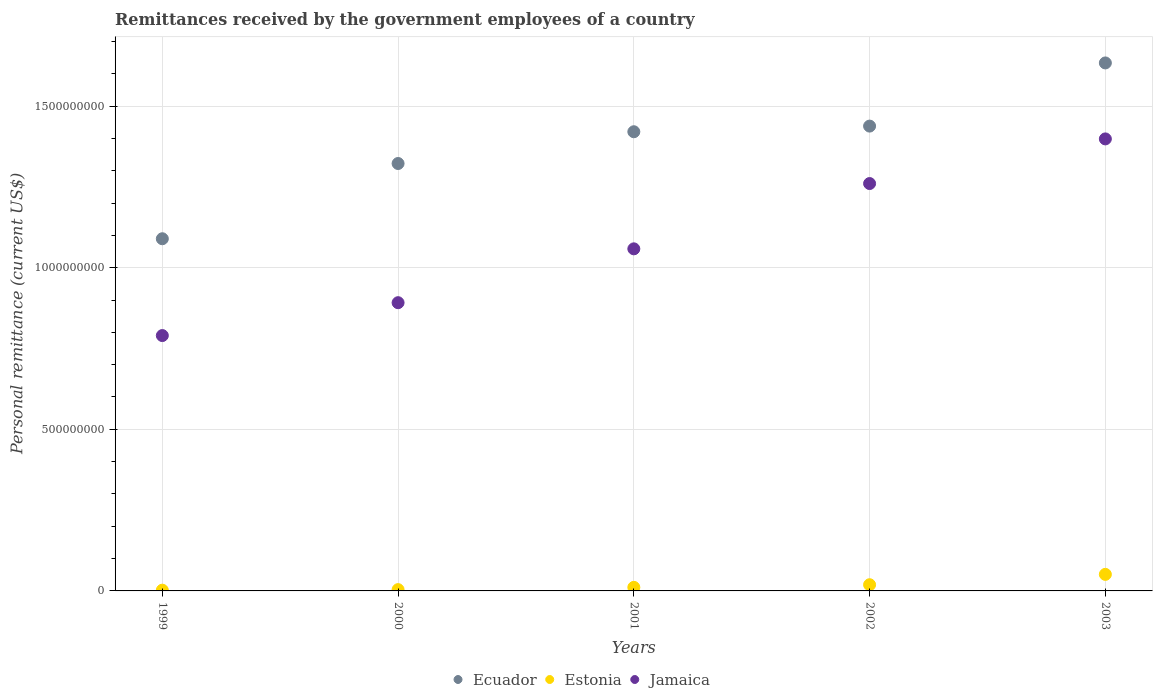How many different coloured dotlines are there?
Your answer should be very brief. 3. Is the number of dotlines equal to the number of legend labels?
Provide a succinct answer. Yes. What is the remittances received by the government employees in Ecuador in 2003?
Provide a short and direct response. 1.63e+09. Across all years, what is the maximum remittances received by the government employees in Ecuador?
Provide a short and direct response. 1.63e+09. Across all years, what is the minimum remittances received by the government employees in Ecuador?
Provide a short and direct response. 1.09e+09. What is the total remittances received by the government employees in Ecuador in the graph?
Your response must be concise. 6.90e+09. What is the difference between the remittances received by the government employees in Ecuador in 1999 and that in 2001?
Provide a succinct answer. -3.31e+08. What is the difference between the remittances received by the government employees in Estonia in 1999 and the remittances received by the government employees in Jamaica in 2001?
Ensure brevity in your answer.  -1.06e+09. What is the average remittances received by the government employees in Estonia per year?
Keep it short and to the point. 1.75e+07. In the year 2000, what is the difference between the remittances received by the government employees in Ecuador and remittances received by the government employees in Jamaica?
Offer a very short reply. 4.31e+08. In how many years, is the remittances received by the government employees in Jamaica greater than 1300000000 US$?
Your answer should be very brief. 1. What is the ratio of the remittances received by the government employees in Estonia in 2000 to that in 2001?
Give a very brief answer. 0.37. What is the difference between the highest and the second highest remittances received by the government employees in Jamaica?
Your answer should be compact. 1.38e+08. What is the difference between the highest and the lowest remittances received by the government employees in Ecuador?
Provide a short and direct response. 5.44e+08. Is it the case that in every year, the sum of the remittances received by the government employees in Jamaica and remittances received by the government employees in Ecuador  is greater than the remittances received by the government employees in Estonia?
Provide a succinct answer. Yes. Does the remittances received by the government employees in Jamaica monotonically increase over the years?
Provide a succinct answer. Yes. Is the remittances received by the government employees in Estonia strictly less than the remittances received by the government employees in Jamaica over the years?
Ensure brevity in your answer.  Yes. How many dotlines are there?
Offer a very short reply. 3. How many years are there in the graph?
Your response must be concise. 5. What is the difference between two consecutive major ticks on the Y-axis?
Your response must be concise. 5.00e+08. Does the graph contain grids?
Ensure brevity in your answer.  Yes. Where does the legend appear in the graph?
Provide a succinct answer. Bottom center. How many legend labels are there?
Offer a very short reply. 3. How are the legend labels stacked?
Offer a very short reply. Horizontal. What is the title of the graph?
Your answer should be compact. Remittances received by the government employees of a country. What is the label or title of the Y-axis?
Provide a short and direct response. Personal remittance (current US$). What is the Personal remittance (current US$) of Ecuador in 1999?
Your response must be concise. 1.09e+09. What is the Personal remittance (current US$) in Estonia in 1999?
Keep it short and to the point. 2.31e+06. What is the Personal remittance (current US$) of Jamaica in 1999?
Provide a short and direct response. 7.90e+08. What is the Personal remittance (current US$) of Ecuador in 2000?
Provide a succinct answer. 1.32e+09. What is the Personal remittance (current US$) in Estonia in 2000?
Offer a very short reply. 4.05e+06. What is the Personal remittance (current US$) in Jamaica in 2000?
Your response must be concise. 8.92e+08. What is the Personal remittance (current US$) in Ecuador in 2001?
Your response must be concise. 1.42e+09. What is the Personal remittance (current US$) in Estonia in 2001?
Keep it short and to the point. 1.10e+07. What is the Personal remittance (current US$) of Jamaica in 2001?
Ensure brevity in your answer.  1.06e+09. What is the Personal remittance (current US$) in Ecuador in 2002?
Provide a succinct answer. 1.44e+09. What is the Personal remittance (current US$) of Estonia in 2002?
Offer a terse response. 1.91e+07. What is the Personal remittance (current US$) of Jamaica in 2002?
Your response must be concise. 1.26e+09. What is the Personal remittance (current US$) in Ecuador in 2003?
Keep it short and to the point. 1.63e+09. What is the Personal remittance (current US$) in Estonia in 2003?
Ensure brevity in your answer.  5.12e+07. What is the Personal remittance (current US$) of Jamaica in 2003?
Your answer should be compact. 1.40e+09. Across all years, what is the maximum Personal remittance (current US$) in Ecuador?
Make the answer very short. 1.63e+09. Across all years, what is the maximum Personal remittance (current US$) in Estonia?
Provide a succinct answer. 5.12e+07. Across all years, what is the maximum Personal remittance (current US$) of Jamaica?
Your response must be concise. 1.40e+09. Across all years, what is the minimum Personal remittance (current US$) of Ecuador?
Your answer should be very brief. 1.09e+09. Across all years, what is the minimum Personal remittance (current US$) of Estonia?
Your answer should be very brief. 2.31e+06. Across all years, what is the minimum Personal remittance (current US$) of Jamaica?
Your response must be concise. 7.90e+08. What is the total Personal remittance (current US$) of Ecuador in the graph?
Offer a terse response. 6.90e+09. What is the total Personal remittance (current US$) in Estonia in the graph?
Your answer should be very brief. 8.77e+07. What is the total Personal remittance (current US$) of Jamaica in the graph?
Provide a succinct answer. 5.40e+09. What is the difference between the Personal remittance (current US$) of Ecuador in 1999 and that in 2000?
Your answer should be very brief. -2.33e+08. What is the difference between the Personal remittance (current US$) in Estonia in 1999 and that in 2000?
Your answer should be very brief. -1.74e+06. What is the difference between the Personal remittance (current US$) in Jamaica in 1999 and that in 2000?
Your response must be concise. -1.02e+08. What is the difference between the Personal remittance (current US$) in Ecuador in 1999 and that in 2001?
Your response must be concise. -3.31e+08. What is the difference between the Personal remittance (current US$) of Estonia in 1999 and that in 2001?
Offer a terse response. -8.71e+06. What is the difference between the Personal remittance (current US$) of Jamaica in 1999 and that in 2001?
Your answer should be compact. -2.68e+08. What is the difference between the Personal remittance (current US$) in Ecuador in 1999 and that in 2002?
Keep it short and to the point. -3.49e+08. What is the difference between the Personal remittance (current US$) in Estonia in 1999 and that in 2002?
Provide a succinct answer. -1.68e+07. What is the difference between the Personal remittance (current US$) of Jamaica in 1999 and that in 2002?
Keep it short and to the point. -4.70e+08. What is the difference between the Personal remittance (current US$) in Ecuador in 1999 and that in 2003?
Your answer should be very brief. -5.44e+08. What is the difference between the Personal remittance (current US$) in Estonia in 1999 and that in 2003?
Offer a terse response. -4.89e+07. What is the difference between the Personal remittance (current US$) of Jamaica in 1999 and that in 2003?
Offer a terse response. -6.08e+08. What is the difference between the Personal remittance (current US$) in Ecuador in 2000 and that in 2001?
Make the answer very short. -9.83e+07. What is the difference between the Personal remittance (current US$) in Estonia in 2000 and that in 2001?
Offer a very short reply. -6.97e+06. What is the difference between the Personal remittance (current US$) in Jamaica in 2000 and that in 2001?
Ensure brevity in your answer.  -1.67e+08. What is the difference between the Personal remittance (current US$) in Ecuador in 2000 and that in 2002?
Give a very brief answer. -1.16e+08. What is the difference between the Personal remittance (current US$) in Estonia in 2000 and that in 2002?
Ensure brevity in your answer.  -1.51e+07. What is the difference between the Personal remittance (current US$) of Jamaica in 2000 and that in 2002?
Make the answer very short. -3.69e+08. What is the difference between the Personal remittance (current US$) in Ecuador in 2000 and that in 2003?
Give a very brief answer. -3.11e+08. What is the difference between the Personal remittance (current US$) of Estonia in 2000 and that in 2003?
Make the answer very short. -4.72e+07. What is the difference between the Personal remittance (current US$) of Jamaica in 2000 and that in 2003?
Ensure brevity in your answer.  -5.07e+08. What is the difference between the Personal remittance (current US$) in Ecuador in 2001 and that in 2002?
Keep it short and to the point. -1.75e+07. What is the difference between the Personal remittance (current US$) of Estonia in 2001 and that in 2002?
Your answer should be compact. -8.13e+06. What is the difference between the Personal remittance (current US$) in Jamaica in 2001 and that in 2002?
Provide a short and direct response. -2.02e+08. What is the difference between the Personal remittance (current US$) of Ecuador in 2001 and that in 2003?
Offer a very short reply. -2.13e+08. What is the difference between the Personal remittance (current US$) in Estonia in 2001 and that in 2003?
Your answer should be compact. -4.02e+07. What is the difference between the Personal remittance (current US$) of Jamaica in 2001 and that in 2003?
Provide a short and direct response. -3.40e+08. What is the difference between the Personal remittance (current US$) in Ecuador in 2002 and that in 2003?
Your answer should be compact. -1.95e+08. What is the difference between the Personal remittance (current US$) of Estonia in 2002 and that in 2003?
Make the answer very short. -3.21e+07. What is the difference between the Personal remittance (current US$) of Jamaica in 2002 and that in 2003?
Keep it short and to the point. -1.38e+08. What is the difference between the Personal remittance (current US$) in Ecuador in 1999 and the Personal remittance (current US$) in Estonia in 2000?
Make the answer very short. 1.09e+09. What is the difference between the Personal remittance (current US$) of Ecuador in 1999 and the Personal remittance (current US$) of Jamaica in 2000?
Keep it short and to the point. 1.98e+08. What is the difference between the Personal remittance (current US$) of Estonia in 1999 and the Personal remittance (current US$) of Jamaica in 2000?
Offer a terse response. -8.89e+08. What is the difference between the Personal remittance (current US$) in Ecuador in 1999 and the Personal remittance (current US$) in Estonia in 2001?
Keep it short and to the point. 1.08e+09. What is the difference between the Personal remittance (current US$) of Ecuador in 1999 and the Personal remittance (current US$) of Jamaica in 2001?
Your answer should be very brief. 3.12e+07. What is the difference between the Personal remittance (current US$) in Estonia in 1999 and the Personal remittance (current US$) in Jamaica in 2001?
Ensure brevity in your answer.  -1.06e+09. What is the difference between the Personal remittance (current US$) of Ecuador in 1999 and the Personal remittance (current US$) of Estonia in 2002?
Keep it short and to the point. 1.07e+09. What is the difference between the Personal remittance (current US$) in Ecuador in 1999 and the Personal remittance (current US$) in Jamaica in 2002?
Your response must be concise. -1.71e+08. What is the difference between the Personal remittance (current US$) in Estonia in 1999 and the Personal remittance (current US$) in Jamaica in 2002?
Offer a very short reply. -1.26e+09. What is the difference between the Personal remittance (current US$) of Ecuador in 1999 and the Personal remittance (current US$) of Estonia in 2003?
Provide a short and direct response. 1.04e+09. What is the difference between the Personal remittance (current US$) of Ecuador in 1999 and the Personal remittance (current US$) of Jamaica in 2003?
Provide a short and direct response. -3.09e+08. What is the difference between the Personal remittance (current US$) in Estonia in 1999 and the Personal remittance (current US$) in Jamaica in 2003?
Your response must be concise. -1.40e+09. What is the difference between the Personal remittance (current US$) of Ecuador in 2000 and the Personal remittance (current US$) of Estonia in 2001?
Offer a very short reply. 1.31e+09. What is the difference between the Personal remittance (current US$) of Ecuador in 2000 and the Personal remittance (current US$) of Jamaica in 2001?
Provide a short and direct response. 2.64e+08. What is the difference between the Personal remittance (current US$) of Estonia in 2000 and the Personal remittance (current US$) of Jamaica in 2001?
Give a very brief answer. -1.05e+09. What is the difference between the Personal remittance (current US$) in Ecuador in 2000 and the Personal remittance (current US$) in Estonia in 2002?
Your response must be concise. 1.30e+09. What is the difference between the Personal remittance (current US$) of Ecuador in 2000 and the Personal remittance (current US$) of Jamaica in 2002?
Provide a succinct answer. 6.20e+07. What is the difference between the Personal remittance (current US$) of Estonia in 2000 and the Personal remittance (current US$) of Jamaica in 2002?
Offer a very short reply. -1.26e+09. What is the difference between the Personal remittance (current US$) of Ecuador in 2000 and the Personal remittance (current US$) of Estonia in 2003?
Your answer should be very brief. 1.27e+09. What is the difference between the Personal remittance (current US$) of Ecuador in 2000 and the Personal remittance (current US$) of Jamaica in 2003?
Your answer should be very brief. -7.61e+07. What is the difference between the Personal remittance (current US$) in Estonia in 2000 and the Personal remittance (current US$) in Jamaica in 2003?
Offer a very short reply. -1.39e+09. What is the difference between the Personal remittance (current US$) in Ecuador in 2001 and the Personal remittance (current US$) in Estonia in 2002?
Keep it short and to the point. 1.40e+09. What is the difference between the Personal remittance (current US$) in Ecuador in 2001 and the Personal remittance (current US$) in Jamaica in 2002?
Give a very brief answer. 1.60e+08. What is the difference between the Personal remittance (current US$) of Estonia in 2001 and the Personal remittance (current US$) of Jamaica in 2002?
Make the answer very short. -1.25e+09. What is the difference between the Personal remittance (current US$) of Ecuador in 2001 and the Personal remittance (current US$) of Estonia in 2003?
Your answer should be very brief. 1.37e+09. What is the difference between the Personal remittance (current US$) in Ecuador in 2001 and the Personal remittance (current US$) in Jamaica in 2003?
Offer a very short reply. 2.22e+07. What is the difference between the Personal remittance (current US$) in Estonia in 2001 and the Personal remittance (current US$) in Jamaica in 2003?
Your answer should be compact. -1.39e+09. What is the difference between the Personal remittance (current US$) of Ecuador in 2002 and the Personal remittance (current US$) of Estonia in 2003?
Make the answer very short. 1.39e+09. What is the difference between the Personal remittance (current US$) in Ecuador in 2002 and the Personal remittance (current US$) in Jamaica in 2003?
Offer a terse response. 3.96e+07. What is the difference between the Personal remittance (current US$) in Estonia in 2002 and the Personal remittance (current US$) in Jamaica in 2003?
Provide a succinct answer. -1.38e+09. What is the average Personal remittance (current US$) in Ecuador per year?
Make the answer very short. 1.38e+09. What is the average Personal remittance (current US$) in Estonia per year?
Your answer should be compact. 1.75e+07. What is the average Personal remittance (current US$) in Jamaica per year?
Keep it short and to the point. 1.08e+09. In the year 1999, what is the difference between the Personal remittance (current US$) of Ecuador and Personal remittance (current US$) of Estonia?
Your answer should be very brief. 1.09e+09. In the year 1999, what is the difference between the Personal remittance (current US$) in Ecuador and Personal remittance (current US$) in Jamaica?
Give a very brief answer. 3.00e+08. In the year 1999, what is the difference between the Personal remittance (current US$) in Estonia and Personal remittance (current US$) in Jamaica?
Provide a succinct answer. -7.88e+08. In the year 2000, what is the difference between the Personal remittance (current US$) of Ecuador and Personal remittance (current US$) of Estonia?
Provide a succinct answer. 1.32e+09. In the year 2000, what is the difference between the Personal remittance (current US$) of Ecuador and Personal remittance (current US$) of Jamaica?
Give a very brief answer. 4.31e+08. In the year 2000, what is the difference between the Personal remittance (current US$) of Estonia and Personal remittance (current US$) of Jamaica?
Offer a terse response. -8.88e+08. In the year 2001, what is the difference between the Personal remittance (current US$) of Ecuador and Personal remittance (current US$) of Estonia?
Ensure brevity in your answer.  1.41e+09. In the year 2001, what is the difference between the Personal remittance (current US$) in Ecuador and Personal remittance (current US$) in Jamaica?
Provide a short and direct response. 3.62e+08. In the year 2001, what is the difference between the Personal remittance (current US$) of Estonia and Personal remittance (current US$) of Jamaica?
Provide a succinct answer. -1.05e+09. In the year 2002, what is the difference between the Personal remittance (current US$) of Ecuador and Personal remittance (current US$) of Estonia?
Offer a terse response. 1.42e+09. In the year 2002, what is the difference between the Personal remittance (current US$) in Ecuador and Personal remittance (current US$) in Jamaica?
Offer a very short reply. 1.78e+08. In the year 2002, what is the difference between the Personal remittance (current US$) of Estonia and Personal remittance (current US$) of Jamaica?
Offer a very short reply. -1.24e+09. In the year 2003, what is the difference between the Personal remittance (current US$) in Ecuador and Personal remittance (current US$) in Estonia?
Make the answer very short. 1.58e+09. In the year 2003, what is the difference between the Personal remittance (current US$) in Ecuador and Personal remittance (current US$) in Jamaica?
Your answer should be very brief. 2.35e+08. In the year 2003, what is the difference between the Personal remittance (current US$) in Estonia and Personal remittance (current US$) in Jamaica?
Make the answer very short. -1.35e+09. What is the ratio of the Personal remittance (current US$) of Ecuador in 1999 to that in 2000?
Give a very brief answer. 0.82. What is the ratio of the Personal remittance (current US$) of Estonia in 1999 to that in 2000?
Offer a very short reply. 0.57. What is the ratio of the Personal remittance (current US$) of Jamaica in 1999 to that in 2000?
Provide a short and direct response. 0.89. What is the ratio of the Personal remittance (current US$) of Ecuador in 1999 to that in 2001?
Offer a terse response. 0.77. What is the ratio of the Personal remittance (current US$) in Estonia in 1999 to that in 2001?
Make the answer very short. 0.21. What is the ratio of the Personal remittance (current US$) in Jamaica in 1999 to that in 2001?
Make the answer very short. 0.75. What is the ratio of the Personal remittance (current US$) in Ecuador in 1999 to that in 2002?
Your answer should be compact. 0.76. What is the ratio of the Personal remittance (current US$) of Estonia in 1999 to that in 2002?
Offer a very short reply. 0.12. What is the ratio of the Personal remittance (current US$) in Jamaica in 1999 to that in 2002?
Offer a terse response. 0.63. What is the ratio of the Personal remittance (current US$) in Ecuador in 1999 to that in 2003?
Ensure brevity in your answer.  0.67. What is the ratio of the Personal remittance (current US$) in Estonia in 1999 to that in 2003?
Provide a short and direct response. 0.05. What is the ratio of the Personal remittance (current US$) of Jamaica in 1999 to that in 2003?
Provide a short and direct response. 0.56. What is the ratio of the Personal remittance (current US$) in Ecuador in 2000 to that in 2001?
Offer a very short reply. 0.93. What is the ratio of the Personal remittance (current US$) in Estonia in 2000 to that in 2001?
Offer a very short reply. 0.37. What is the ratio of the Personal remittance (current US$) in Jamaica in 2000 to that in 2001?
Provide a succinct answer. 0.84. What is the ratio of the Personal remittance (current US$) in Ecuador in 2000 to that in 2002?
Give a very brief answer. 0.92. What is the ratio of the Personal remittance (current US$) of Estonia in 2000 to that in 2002?
Ensure brevity in your answer.  0.21. What is the ratio of the Personal remittance (current US$) in Jamaica in 2000 to that in 2002?
Give a very brief answer. 0.71. What is the ratio of the Personal remittance (current US$) in Ecuador in 2000 to that in 2003?
Your response must be concise. 0.81. What is the ratio of the Personal remittance (current US$) in Estonia in 2000 to that in 2003?
Offer a terse response. 0.08. What is the ratio of the Personal remittance (current US$) of Jamaica in 2000 to that in 2003?
Your answer should be very brief. 0.64. What is the ratio of the Personal remittance (current US$) in Ecuador in 2001 to that in 2002?
Ensure brevity in your answer.  0.99. What is the ratio of the Personal remittance (current US$) in Estonia in 2001 to that in 2002?
Ensure brevity in your answer.  0.58. What is the ratio of the Personal remittance (current US$) in Jamaica in 2001 to that in 2002?
Make the answer very short. 0.84. What is the ratio of the Personal remittance (current US$) in Ecuador in 2001 to that in 2003?
Offer a very short reply. 0.87. What is the ratio of the Personal remittance (current US$) in Estonia in 2001 to that in 2003?
Keep it short and to the point. 0.22. What is the ratio of the Personal remittance (current US$) of Jamaica in 2001 to that in 2003?
Give a very brief answer. 0.76. What is the ratio of the Personal remittance (current US$) in Ecuador in 2002 to that in 2003?
Your answer should be compact. 0.88. What is the ratio of the Personal remittance (current US$) in Estonia in 2002 to that in 2003?
Offer a terse response. 0.37. What is the ratio of the Personal remittance (current US$) of Jamaica in 2002 to that in 2003?
Your response must be concise. 0.9. What is the difference between the highest and the second highest Personal remittance (current US$) in Ecuador?
Offer a terse response. 1.95e+08. What is the difference between the highest and the second highest Personal remittance (current US$) of Estonia?
Ensure brevity in your answer.  3.21e+07. What is the difference between the highest and the second highest Personal remittance (current US$) of Jamaica?
Give a very brief answer. 1.38e+08. What is the difference between the highest and the lowest Personal remittance (current US$) in Ecuador?
Ensure brevity in your answer.  5.44e+08. What is the difference between the highest and the lowest Personal remittance (current US$) in Estonia?
Your answer should be very brief. 4.89e+07. What is the difference between the highest and the lowest Personal remittance (current US$) in Jamaica?
Give a very brief answer. 6.08e+08. 